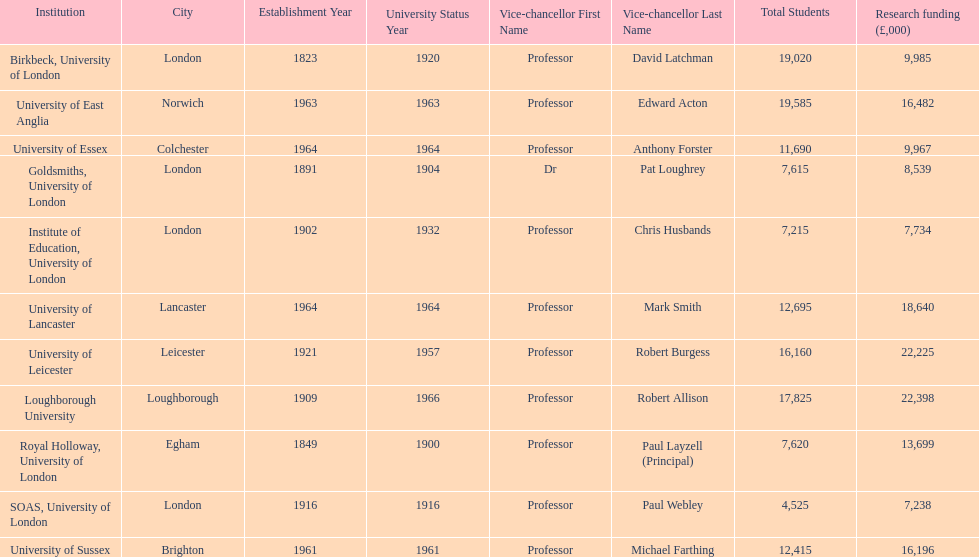Which institution has the most research funding? Loughborough University. 